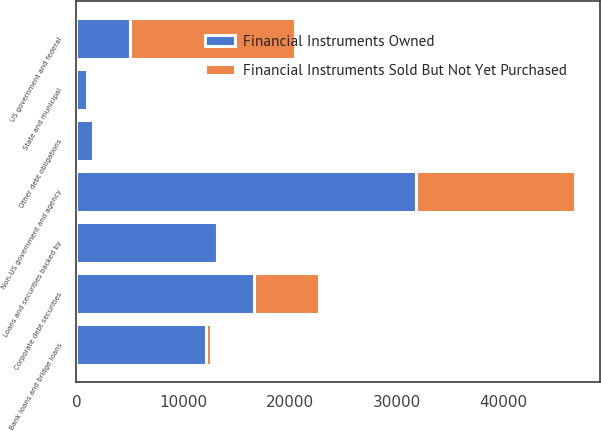Convert chart to OTSL. <chart><loc_0><loc_0><loc_500><loc_500><stacked_bar_chart><ecel><fcel>US government and federal<fcel>Non-US government and agency<fcel>Loans and securities backed by<fcel>Bank loans and bridge loans<fcel>Corporate debt securities<fcel>State and municipal<fcel>Other debt obligations<nl><fcel>Financial Instruments Owned<fcel>4975<fcel>31772<fcel>13183<fcel>12164<fcel>16640<fcel>992<fcel>1595<nl><fcel>Financial Instruments Sold But Not Yet Purchased<fcel>15516<fcel>14973<fcel>2<fcel>461<fcel>6123<fcel>2<fcel>2<nl></chart> 